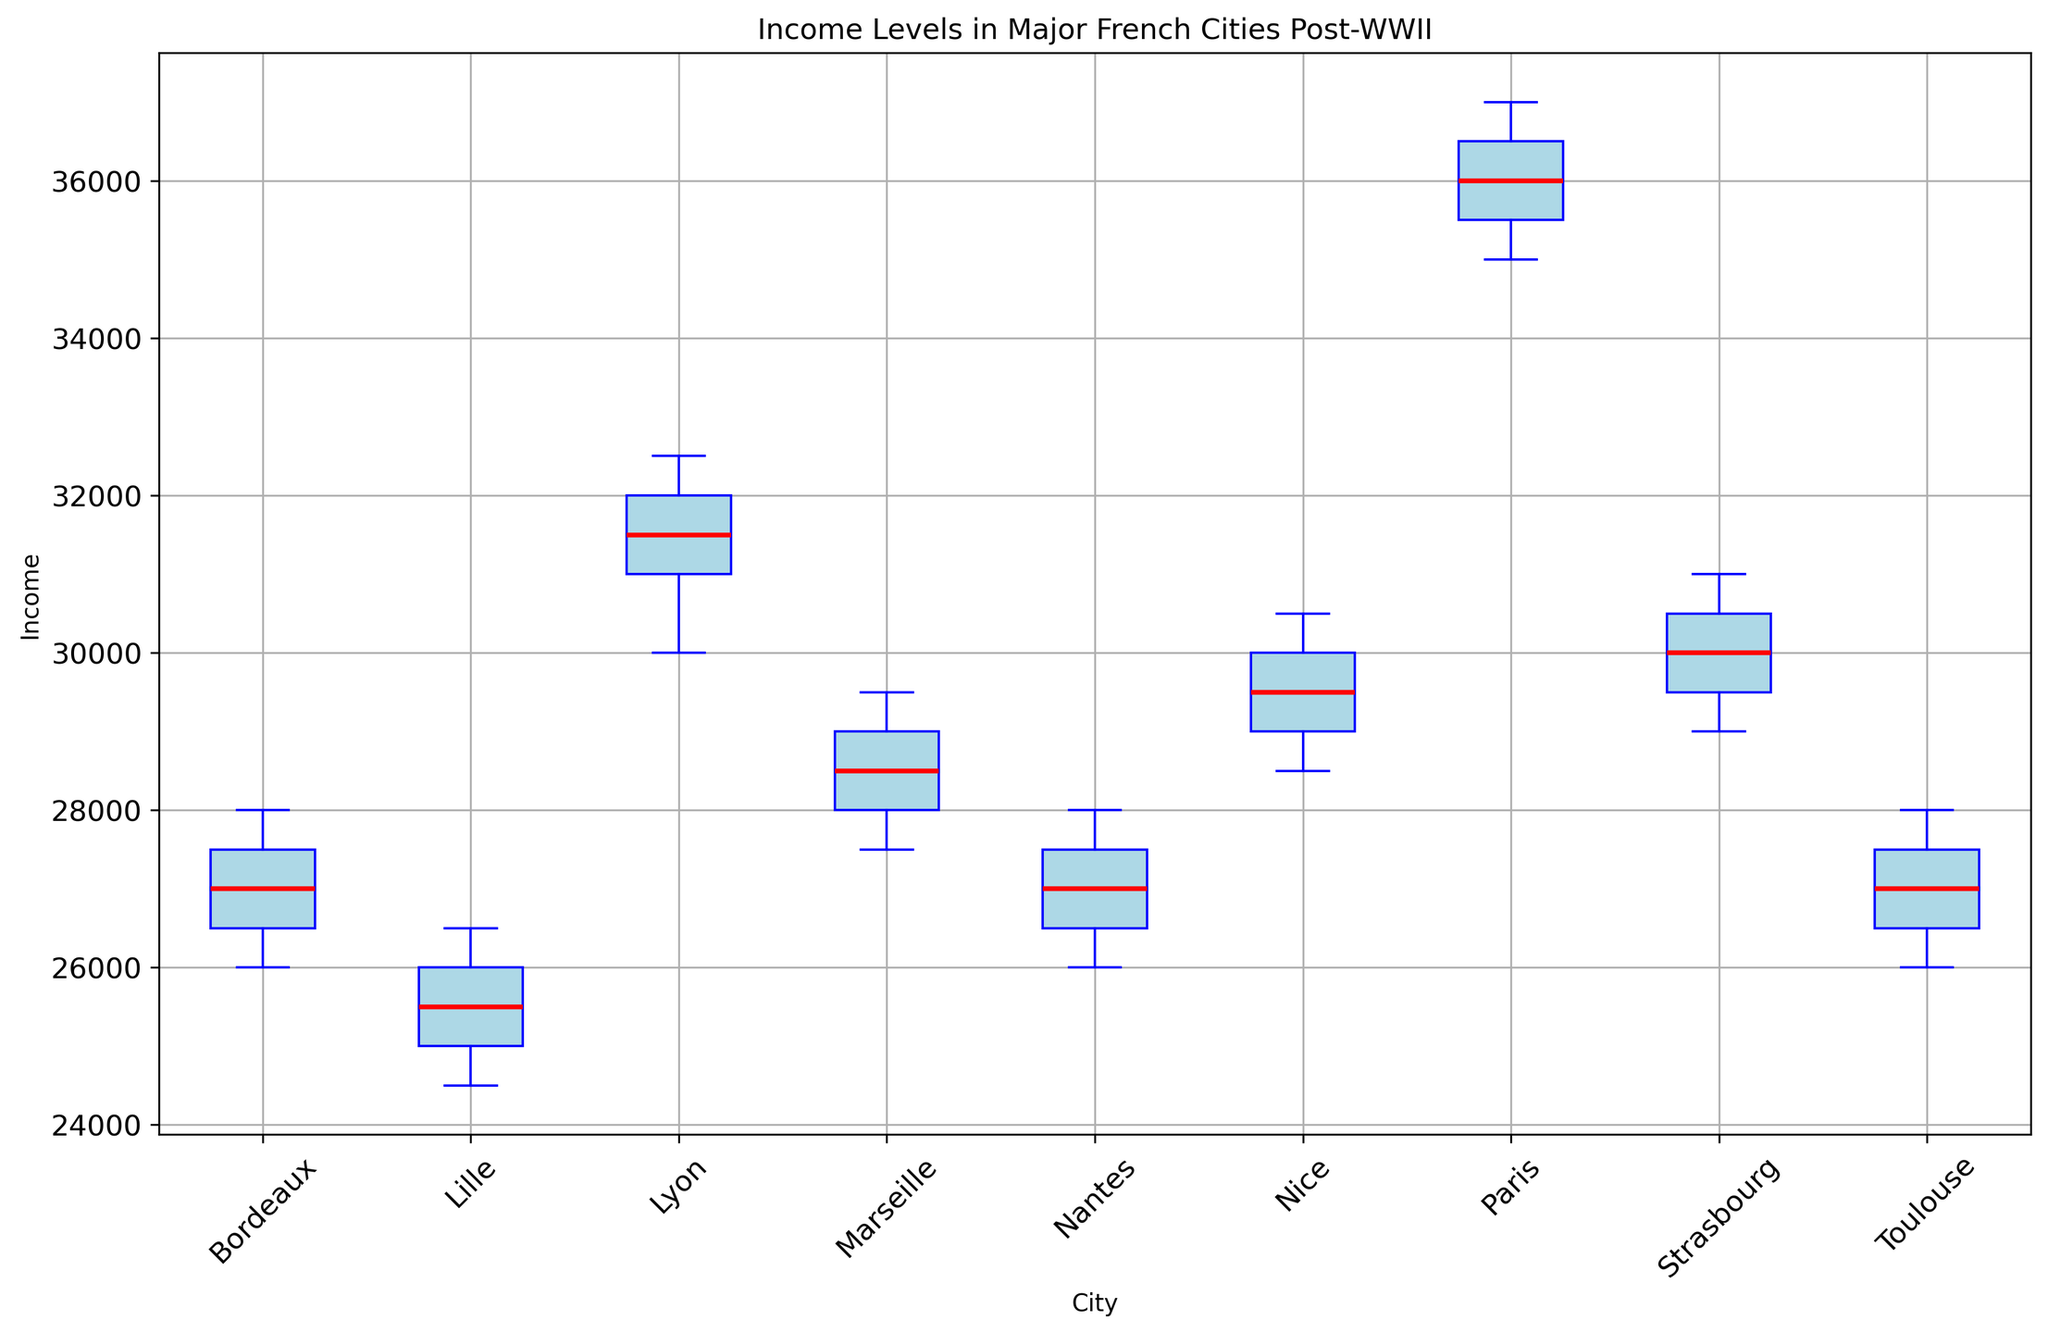What is the median income of Paris compared to Lyon? The median income is identified by the middle value of each city's data. For Paris, the median income is the middle value when sorted, which is 36000. For Lyon, the middle value in the sorted list is 31500. Comparing, Paris has a higher median income than Lyon.
Answer: Paris has a higher median income than Lyon Which city shows the greatest range of income levels? The range is calculated by subtracting the minimum value from the maximum value for each city. For Paris, the range is 37000 - 35000 = 2000. For Marseille, it is 29500 - 27500 = 2000. For Lyon, it is 32500 - 30000 = 2500. For Toulouse, it is 28000 - 26000 = 2000. For Nice, it is 30500 - 28500 = 2000. For Bordeaux, it is 28000 - 26000 = 2000. For Lille, it is 26500 - 24500 = 2000. For Nantes, it is 28000 - 26000 = 2000. For Strasbourg, it is 31000 - 29000 = 2000. Lyon shows the greatest range of 2500.
Answer: Lyon Between Nantes and Strasbourg, which city has a higher upper quartile income? The upper quartile is the median of the upper half of the data. For Nantes, with data 26000, 26500, 27000, 27500, 28000, the upper quartile is 27500. For Strasbourg, with data 29000, 29500, 30000, 30500, 31000, the upper quartile is 30500. Having a higher upper quartile, Strasbourg has a higher upper quartile income.
Answer: Strasbourg Which city has the smallest difference between the upper and lower quartiles? The interquartile range (IQR) is the difference between the upper and lower quartiles. Smaller IQR indicates smaller difference. For Paris, the IQR is 36500 - 35500 = 1000. For Marseille, the IQR is 29000 - 28000 = 1000. For Lyon, the IQR is 32000 - 31000 = 1000. For Toulouse, the IQR is 27500 - 26500 = 1000. For Nice, the IQR is 30000 - 29000 = 1000. For Bordeaux, the IQR is 27500 - 26500 = 1000. For Lille, the IQR is 26000 - 25000 = 1000. For Nantes, the IQR is 27500 - 26500 = 1000. For Strasbourg, the IQR is 30500 - 29500 = 1000. All cities have the smallest IQR of 1000.
Answer: All cities have the same smallest IQR of 1000 How does the income distribution in Marseille compare to Bordeaux? Both cities have the same range (2000) and interquartile range (1000), suggesting similar spread in incomes. However, it can be observed that Marseille has a slightly higher median (28500) compared to Bordeaux (27000). Consequently, Marseille has a slightly higher central tendency.
Answer: Marseille has a slightly higher median Which city is depicted to have the lowest median income? The median income for each city is visualized in the box plot as the central line inside the box. Lille's box plot shows the lowest median income which is around 25500.
Answer: Lille What is a common visual trait among all the cities on the box plot? All cities have box plots with blue colored boxes, blue whiskers, blue caps, and red median lines. Outlier points, if present, are marked with red dots. This consistent coloring emphasizes the comparative analysis between the cities.
Answer: Uniform blue boxes and red median lines Can you describe the spread of income levels in Nice? By examining the box plot for Nice, we can see the interquartile range (IQR) is from approximately 29000 to 30000. The whiskers extend from 28500 to 30500, showing no significant outliers, indicating a relatively narrow spread around the median income, making the distribution less variable.
Answer: Narrow spread, less variable 